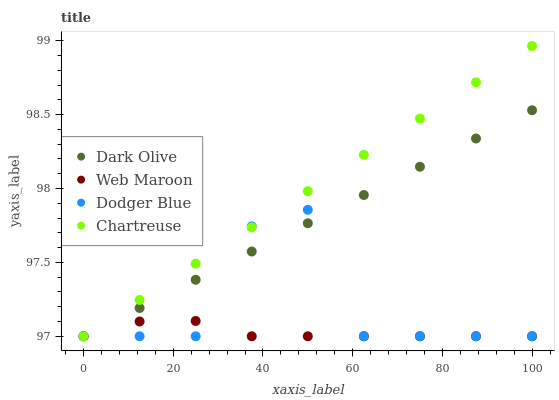Does Web Maroon have the minimum area under the curve?
Answer yes or no. Yes. Does Chartreuse have the maximum area under the curve?
Answer yes or no. Yes. Does Dark Olive have the minimum area under the curve?
Answer yes or no. No. Does Dark Olive have the maximum area under the curve?
Answer yes or no. No. Is Chartreuse the smoothest?
Answer yes or no. Yes. Is Dodger Blue the roughest?
Answer yes or no. Yes. Is Dark Olive the smoothest?
Answer yes or no. No. Is Dark Olive the roughest?
Answer yes or no. No. Does Dodger Blue have the lowest value?
Answer yes or no. Yes. Does Chartreuse have the highest value?
Answer yes or no. Yes. Does Dark Olive have the highest value?
Answer yes or no. No. Does Chartreuse intersect Dodger Blue?
Answer yes or no. Yes. Is Chartreuse less than Dodger Blue?
Answer yes or no. No. Is Chartreuse greater than Dodger Blue?
Answer yes or no. No. 